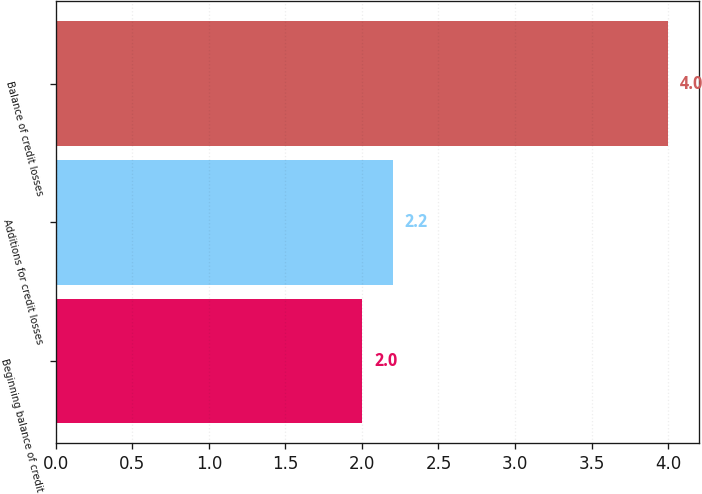Convert chart to OTSL. <chart><loc_0><loc_0><loc_500><loc_500><bar_chart><fcel>Beginning balance of credit<fcel>Additions for credit losses<fcel>Balance of credit losses<nl><fcel>2<fcel>2.2<fcel>4<nl></chart> 